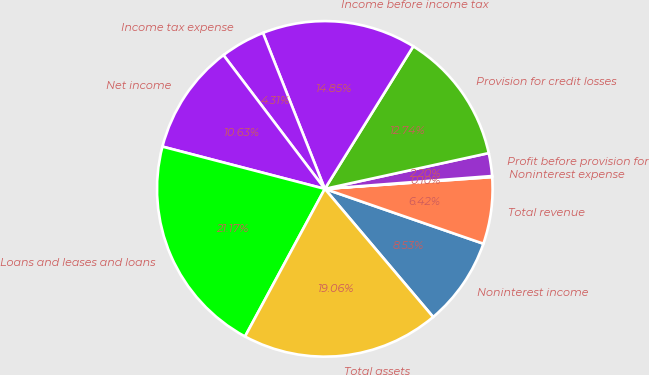Convert chart. <chart><loc_0><loc_0><loc_500><loc_500><pie_chart><fcel>Noninterest income<fcel>Total revenue<fcel>Noninterest expense<fcel>Profit before provision for<fcel>Provision for credit losses<fcel>Income before income tax<fcel>Income tax expense<fcel>Net income<fcel>Loans and leases and loans<fcel>Total assets<nl><fcel>8.53%<fcel>6.42%<fcel>0.1%<fcel>2.2%<fcel>12.74%<fcel>14.85%<fcel>4.31%<fcel>10.63%<fcel>21.17%<fcel>19.06%<nl></chart> 